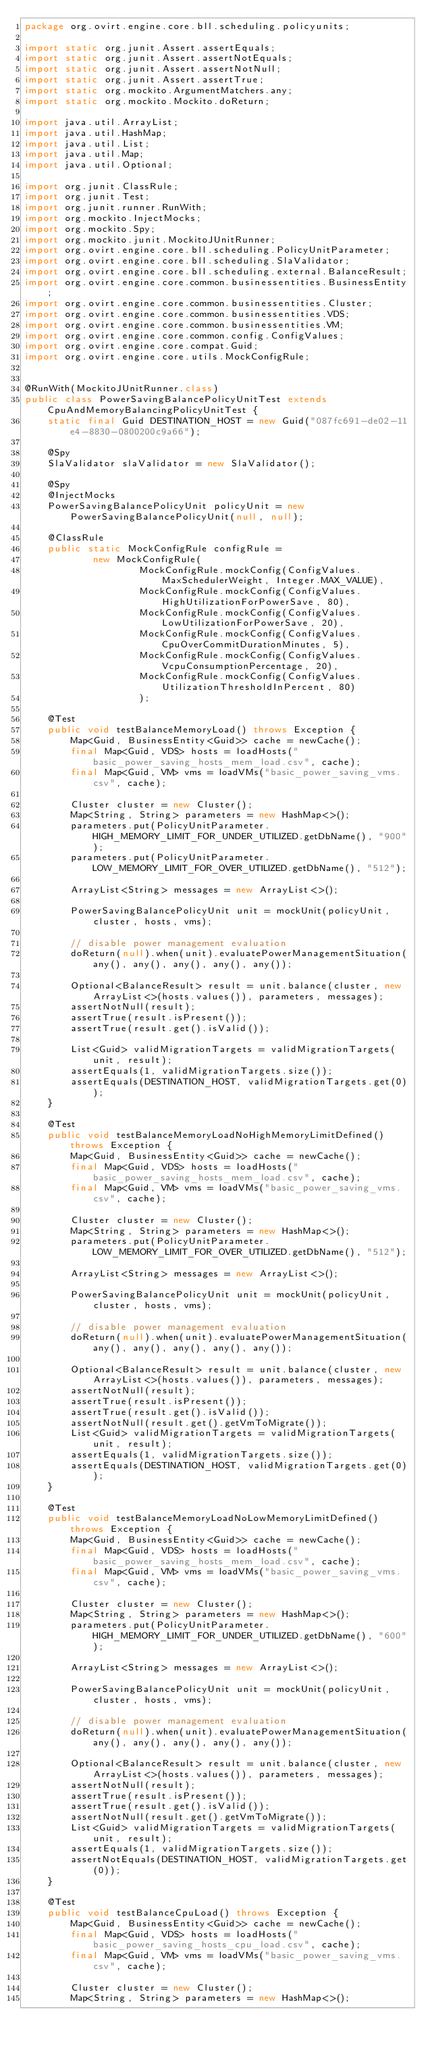<code> <loc_0><loc_0><loc_500><loc_500><_Java_>package org.ovirt.engine.core.bll.scheduling.policyunits;

import static org.junit.Assert.assertEquals;
import static org.junit.Assert.assertNotEquals;
import static org.junit.Assert.assertNotNull;
import static org.junit.Assert.assertTrue;
import static org.mockito.ArgumentMatchers.any;
import static org.mockito.Mockito.doReturn;

import java.util.ArrayList;
import java.util.HashMap;
import java.util.List;
import java.util.Map;
import java.util.Optional;

import org.junit.ClassRule;
import org.junit.Test;
import org.junit.runner.RunWith;
import org.mockito.InjectMocks;
import org.mockito.Spy;
import org.mockito.junit.MockitoJUnitRunner;
import org.ovirt.engine.core.bll.scheduling.PolicyUnitParameter;
import org.ovirt.engine.core.bll.scheduling.SlaValidator;
import org.ovirt.engine.core.bll.scheduling.external.BalanceResult;
import org.ovirt.engine.core.common.businessentities.BusinessEntity;
import org.ovirt.engine.core.common.businessentities.Cluster;
import org.ovirt.engine.core.common.businessentities.VDS;
import org.ovirt.engine.core.common.businessentities.VM;
import org.ovirt.engine.core.common.config.ConfigValues;
import org.ovirt.engine.core.compat.Guid;
import org.ovirt.engine.core.utils.MockConfigRule;


@RunWith(MockitoJUnitRunner.class)
public class PowerSavingBalancePolicyUnitTest extends CpuAndMemoryBalancingPolicyUnitTest {
    static final Guid DESTINATION_HOST = new Guid("087fc691-de02-11e4-8830-0800200c9a66");

    @Spy
    SlaValidator slaValidator = new SlaValidator();

    @Spy
    @InjectMocks
    PowerSavingBalancePolicyUnit policyUnit = new PowerSavingBalancePolicyUnit(null, null);

    @ClassRule
    public static MockConfigRule configRule =
            new MockConfigRule(
                    MockConfigRule.mockConfig(ConfigValues.MaxSchedulerWeight, Integer.MAX_VALUE),
                    MockConfigRule.mockConfig(ConfigValues.HighUtilizationForPowerSave, 80),
                    MockConfigRule.mockConfig(ConfigValues.LowUtilizationForPowerSave, 20),
                    MockConfigRule.mockConfig(ConfigValues.CpuOverCommitDurationMinutes, 5),
                    MockConfigRule.mockConfig(ConfigValues.VcpuConsumptionPercentage, 20),
                    MockConfigRule.mockConfig(ConfigValues.UtilizationThresholdInPercent, 80)
                    );

    @Test
    public void testBalanceMemoryLoad() throws Exception {
        Map<Guid, BusinessEntity<Guid>> cache = newCache();
        final Map<Guid, VDS> hosts = loadHosts("basic_power_saving_hosts_mem_load.csv", cache);
        final Map<Guid, VM> vms = loadVMs("basic_power_saving_vms.csv", cache);

        Cluster cluster = new Cluster();
        Map<String, String> parameters = new HashMap<>();
        parameters.put(PolicyUnitParameter.HIGH_MEMORY_LIMIT_FOR_UNDER_UTILIZED.getDbName(), "900");
        parameters.put(PolicyUnitParameter.LOW_MEMORY_LIMIT_FOR_OVER_UTILIZED.getDbName(), "512");

        ArrayList<String> messages = new ArrayList<>();

        PowerSavingBalancePolicyUnit unit = mockUnit(policyUnit, cluster, hosts, vms);

        // disable power management evaluation
        doReturn(null).when(unit).evaluatePowerManagementSituation(any(), any(), any(), any(), any());

        Optional<BalanceResult> result = unit.balance(cluster, new ArrayList<>(hosts.values()), parameters, messages);
        assertNotNull(result);
        assertTrue(result.isPresent());
        assertTrue(result.get().isValid());

        List<Guid> validMigrationTargets = validMigrationTargets(unit, result);
        assertEquals(1, validMigrationTargets.size());
        assertEquals(DESTINATION_HOST, validMigrationTargets.get(0));
    }

    @Test
    public void testBalanceMemoryLoadNoHighMemoryLimitDefined() throws Exception {
        Map<Guid, BusinessEntity<Guid>> cache = newCache();
        final Map<Guid, VDS> hosts = loadHosts("basic_power_saving_hosts_mem_load.csv", cache);
        final Map<Guid, VM> vms = loadVMs("basic_power_saving_vms.csv", cache);

        Cluster cluster = new Cluster();
        Map<String, String> parameters = new HashMap<>();
        parameters.put(PolicyUnitParameter.LOW_MEMORY_LIMIT_FOR_OVER_UTILIZED.getDbName(), "512");

        ArrayList<String> messages = new ArrayList<>();

        PowerSavingBalancePolicyUnit unit = mockUnit(policyUnit, cluster, hosts, vms);

        // disable power management evaluation
        doReturn(null).when(unit).evaluatePowerManagementSituation(any(), any(), any(), any(), any());

        Optional<BalanceResult> result = unit.balance(cluster, new ArrayList<>(hosts.values()), parameters, messages);
        assertNotNull(result);
        assertTrue(result.isPresent());
        assertTrue(result.get().isValid());
        assertNotNull(result.get().getVmToMigrate());
        List<Guid> validMigrationTargets = validMigrationTargets(unit, result);
        assertEquals(1, validMigrationTargets.size());
        assertEquals(DESTINATION_HOST, validMigrationTargets.get(0));
    }

    @Test
    public void testBalanceMemoryLoadNoLowMemoryLimitDefined() throws Exception {
        Map<Guid, BusinessEntity<Guid>> cache = newCache();
        final Map<Guid, VDS> hosts = loadHosts("basic_power_saving_hosts_mem_load.csv", cache);
        final Map<Guid, VM> vms = loadVMs("basic_power_saving_vms.csv", cache);

        Cluster cluster = new Cluster();
        Map<String, String> parameters = new HashMap<>();
        parameters.put(PolicyUnitParameter.HIGH_MEMORY_LIMIT_FOR_UNDER_UTILIZED.getDbName(), "600");

        ArrayList<String> messages = new ArrayList<>();

        PowerSavingBalancePolicyUnit unit = mockUnit(policyUnit, cluster, hosts, vms);

        // disable power management evaluation
        doReturn(null).when(unit).evaluatePowerManagementSituation(any(), any(), any(), any(), any());

        Optional<BalanceResult> result = unit.balance(cluster, new ArrayList<>(hosts.values()), parameters, messages);
        assertNotNull(result);
        assertTrue(result.isPresent());
        assertTrue(result.get().isValid());
        assertNotNull(result.get().getVmToMigrate());
        List<Guid> validMigrationTargets = validMigrationTargets(unit, result);
        assertEquals(1, validMigrationTargets.size());
        assertNotEquals(DESTINATION_HOST, validMigrationTargets.get(0));
    }

    @Test
    public void testBalanceCpuLoad() throws Exception {
        Map<Guid, BusinessEntity<Guid>> cache = newCache();
        final Map<Guid, VDS> hosts = loadHosts("basic_power_saving_hosts_cpu_load.csv", cache);
        final Map<Guid, VM> vms = loadVMs("basic_power_saving_vms.csv", cache);

        Cluster cluster = new Cluster();
        Map<String, String> parameters = new HashMap<>();</code> 